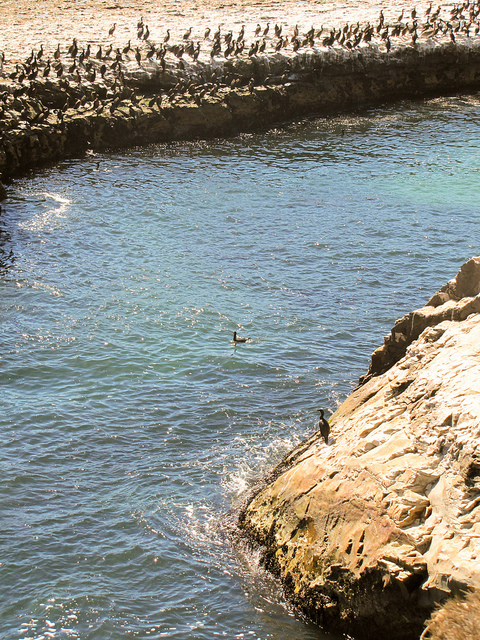Can you tell what time of day it is based on the shadows and lighting in the image? Judging by the shadows cast by the birds and the angle of the sunlight on the water, it appears to be either late morning or early afternoon. The shadows are quite pronounced but not overly elongated, suggesting the sun is high enough in the sky to narrow the angle of the light. Does the position of the sun affect the behavior of the birds in this environment? Yes, the position of the sun plays a significant role in bird behavior. Birds may be more active during cooler parts of the day, like early morning or late afternoon. The warmer midday sun can often lead them to seek shade and reduce activity to conserve energy. 